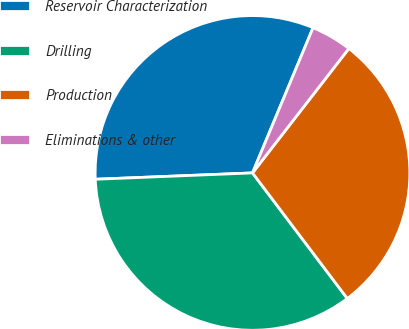<chart> <loc_0><loc_0><loc_500><loc_500><pie_chart><fcel>Reservoir Characterization<fcel>Drilling<fcel>Production<fcel>Eliminations & other<nl><fcel>31.93%<fcel>34.65%<fcel>29.22%<fcel>4.2%<nl></chart> 